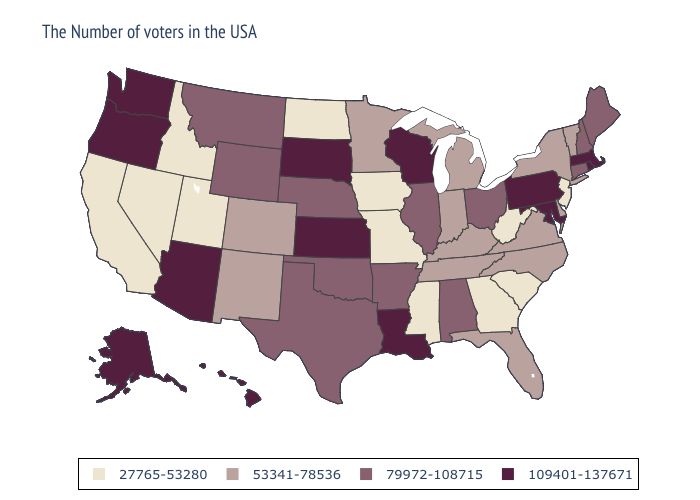Name the states that have a value in the range 109401-137671?
Give a very brief answer. Massachusetts, Rhode Island, Maryland, Pennsylvania, Wisconsin, Louisiana, Kansas, South Dakota, Arizona, Washington, Oregon, Alaska, Hawaii. What is the value of Colorado?
Concise answer only. 53341-78536. Name the states that have a value in the range 109401-137671?
Keep it brief. Massachusetts, Rhode Island, Maryland, Pennsylvania, Wisconsin, Louisiana, Kansas, South Dakota, Arizona, Washington, Oregon, Alaska, Hawaii. Does the map have missing data?
Be succinct. No. Does Missouri have the same value as Minnesota?
Keep it brief. No. Does Oregon have a higher value than Arkansas?
Short answer required. Yes. What is the lowest value in the South?
Write a very short answer. 27765-53280. Which states have the lowest value in the South?
Quick response, please. South Carolina, West Virginia, Georgia, Mississippi. What is the highest value in states that border New York?
Give a very brief answer. 109401-137671. What is the value of California?
Be succinct. 27765-53280. Name the states that have a value in the range 53341-78536?
Give a very brief answer. Vermont, New York, Delaware, Virginia, North Carolina, Florida, Michigan, Kentucky, Indiana, Tennessee, Minnesota, Colorado, New Mexico. Is the legend a continuous bar?
Concise answer only. No. Name the states that have a value in the range 109401-137671?
Keep it brief. Massachusetts, Rhode Island, Maryland, Pennsylvania, Wisconsin, Louisiana, Kansas, South Dakota, Arizona, Washington, Oregon, Alaska, Hawaii. What is the highest value in states that border Vermont?
Short answer required. 109401-137671. Which states have the highest value in the USA?
Concise answer only. Massachusetts, Rhode Island, Maryland, Pennsylvania, Wisconsin, Louisiana, Kansas, South Dakota, Arizona, Washington, Oregon, Alaska, Hawaii. 